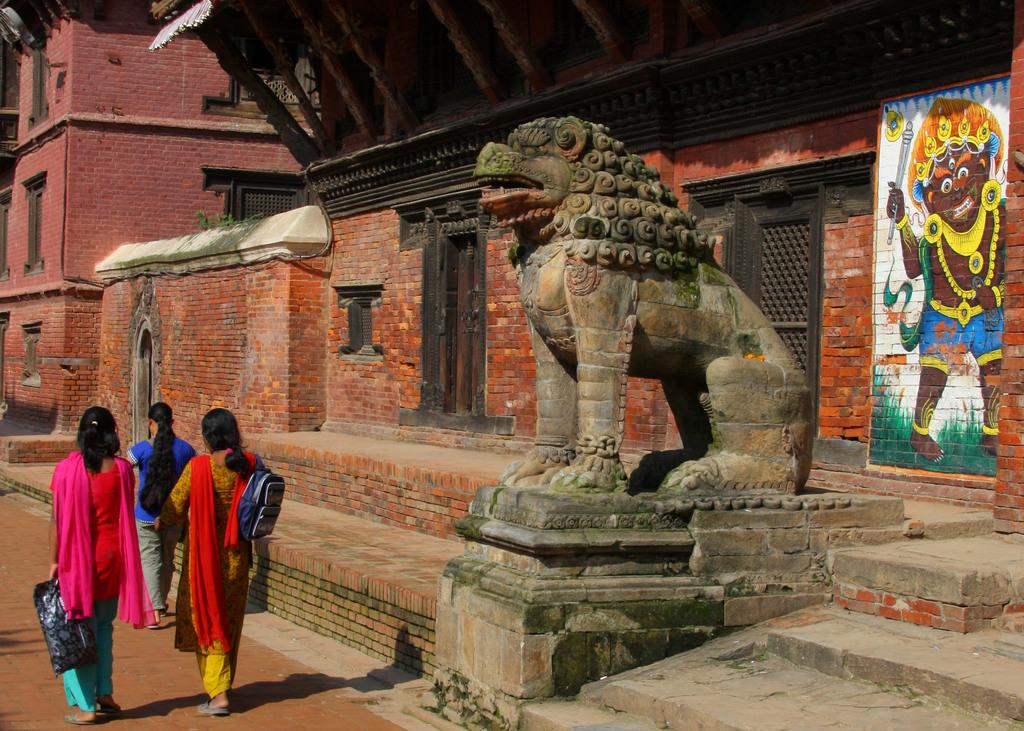What is happening on the ground in the image? There are persons on the ground in the image. What can be seen in the background of the image? There is a statue, buildings, and a wall in the background of the image. How many apples are being processed by the persons in the image? There is no mention of apples or any process involving apples in the image. 